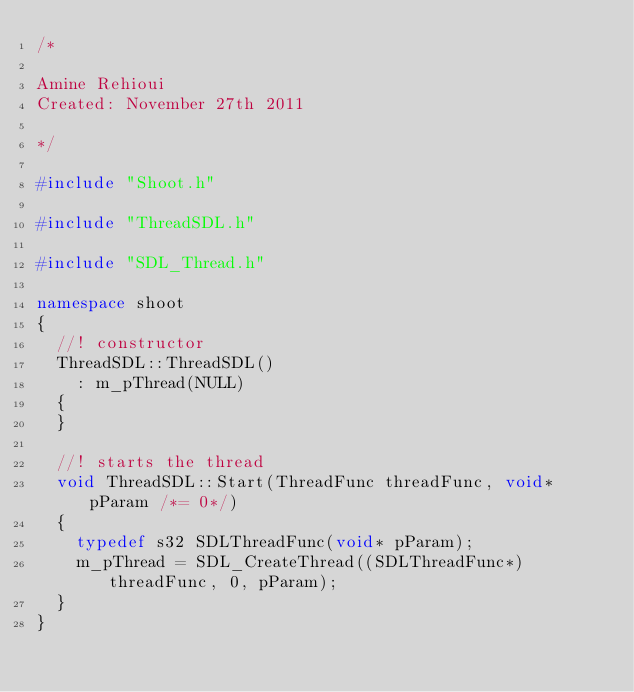<code> <loc_0><loc_0><loc_500><loc_500><_C++_>/* 

Amine Rehioui
Created: November 27th 2011

*/

#include "Shoot.h"

#include "ThreadSDL.h"

#include "SDL_Thread.h"

namespace shoot
{
	//! constructor
	ThreadSDL::ThreadSDL()
		: m_pThread(NULL)
	{
	}

	//! starts the thread
	void ThreadSDL::Start(ThreadFunc threadFunc, void* pParam /*= 0*/)
	{
		typedef s32 SDLThreadFunc(void* pParam);
		m_pThread = SDL_CreateThread((SDLThreadFunc*)threadFunc, 0, pParam);
	}
}

</code> 